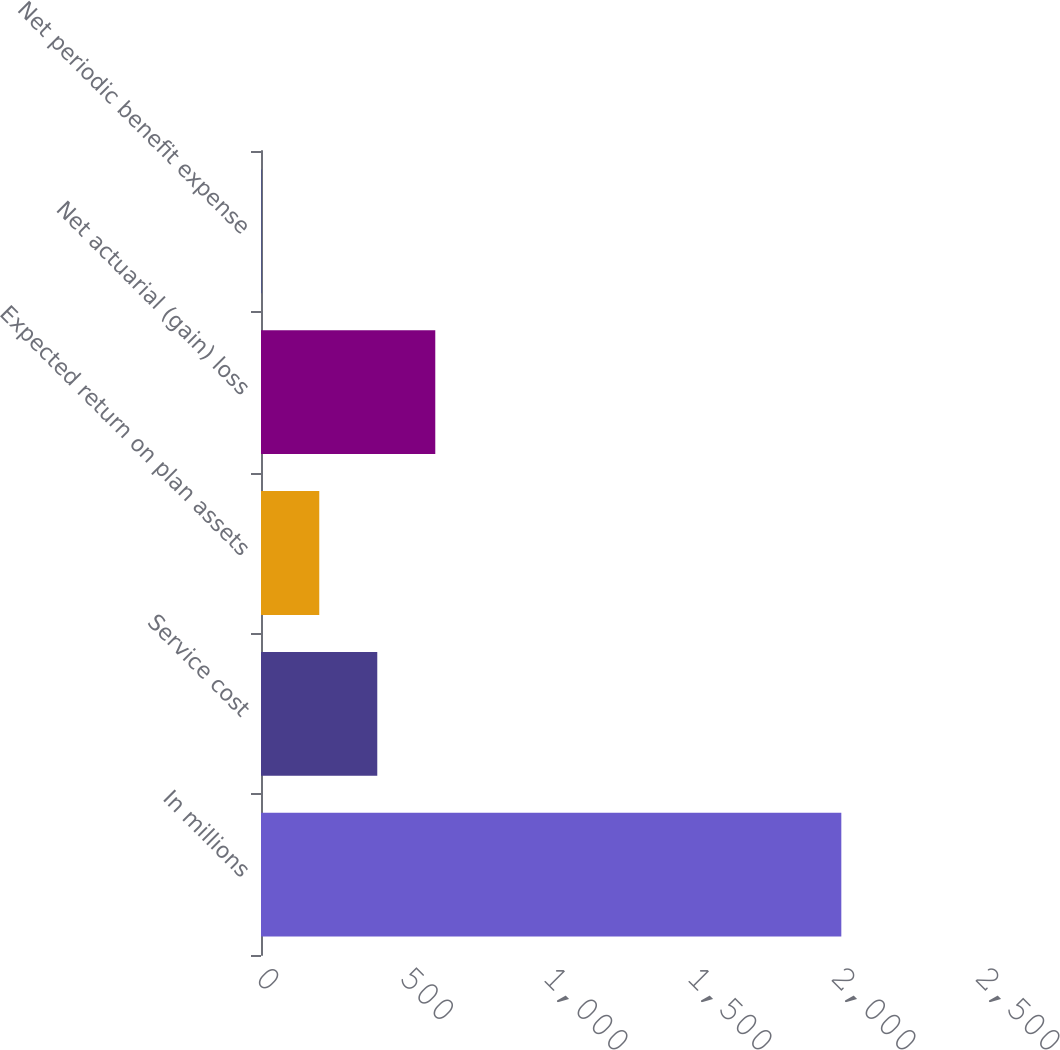Convert chart. <chart><loc_0><loc_0><loc_500><loc_500><bar_chart><fcel>In millions<fcel>Service cost<fcel>Expected return on plan assets<fcel>Net actuarial (gain) loss<fcel>Net periodic benefit expense<nl><fcel>2015<fcel>403.72<fcel>202.31<fcel>605.13<fcel>0.9<nl></chart> 